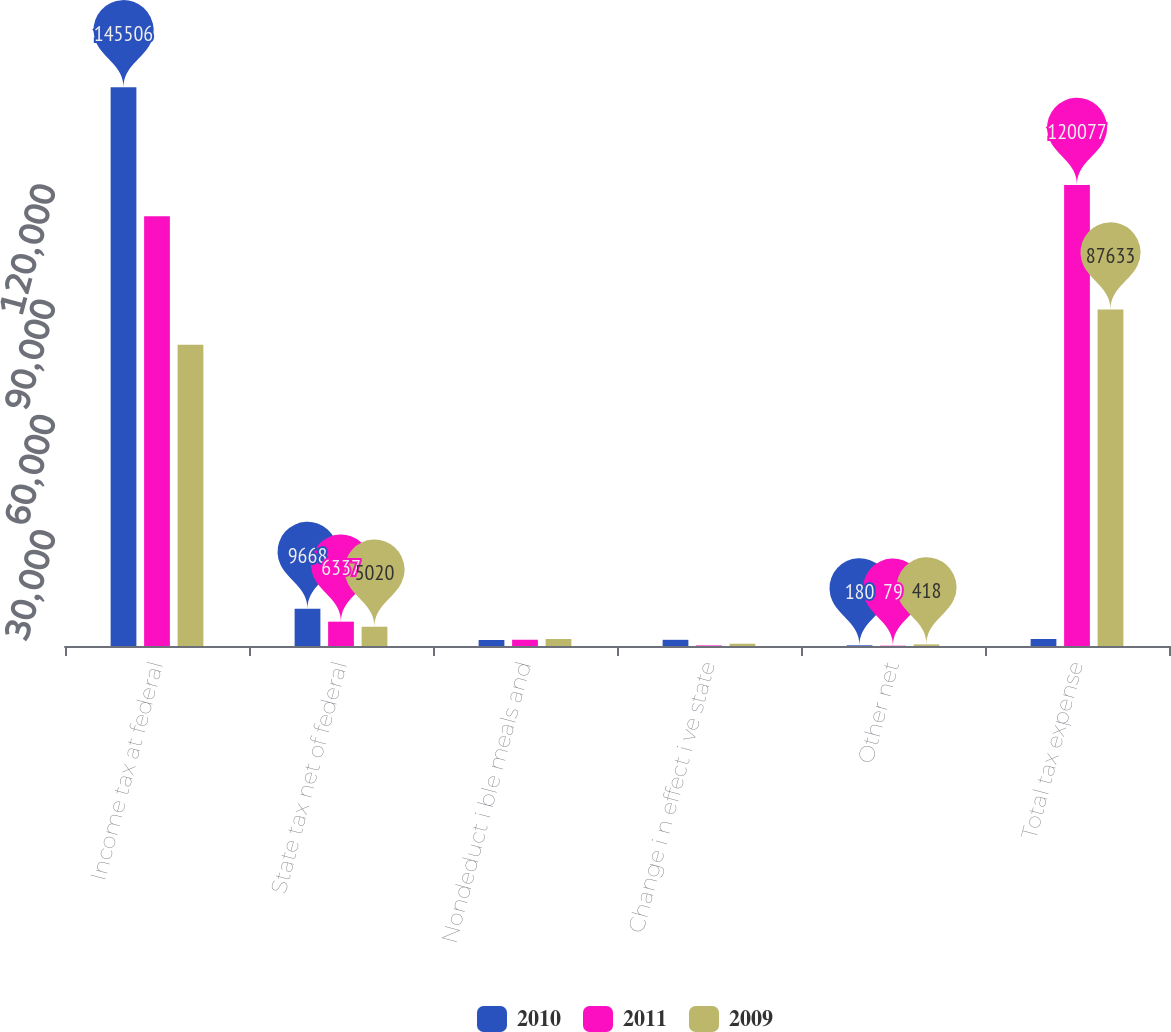Convert chart to OTSL. <chart><loc_0><loc_0><loc_500><loc_500><stacked_bar_chart><ecel><fcel>Income tax at federal<fcel>State tax net of federal<fcel>Nondeduct i ble meals and<fcel>Change i n effect i ve state<fcel>Other net<fcel>Total tax expense<nl><fcel>2010<fcel>145506<fcel>9668<fcel>1570<fcel>1611<fcel>180<fcel>1818<nl><fcel>2011<fcel>111893<fcel>6337<fcel>1627<fcel>141<fcel>79<fcel>120077<nl><fcel>2009<fcel>78424<fcel>5020<fcel>1818<fcel>592<fcel>418<fcel>87633<nl></chart> 